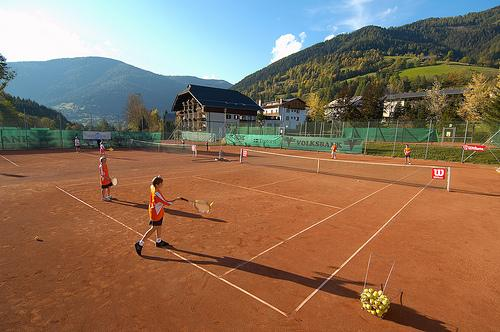Choose the correct referential expression: "The person in a black skirt is _____" Just standing there. What is the primary action being taken by the tennis player? A tennis player swinging a racket on an orange clay court. Based on the image description, determine whether or not the setting seems to be a professional or casual tennis game. The setting appears to be more casual, as there are various players, equipment, and clay courts. List three objects related to tennis that can be seen in the image. A tennis racket, a tennis ball, and a tennis court net. What objects can you find near the net and what color are they? A tennis ball near the net is white and the banner in the back is green. Describe the tennis court's surface and what makes it distinct. The tennis court's surface is orange and red clay, which gives it a unique look and texture. Imagine a brand using this image for an advertisement. Describe the core message they would be trying to convey. Experience the spirit and intensity of tennis on a clay court, surrounded by nature's astounding beauty. Identify the types of footwear worn by the various individuals in the image. White tennis shoes, black tennis shoes, and black sneakers. Describe the role of mountains and trees in this picture. Mountains and trees provide a serene, picturesque backdrop for the tennis game. Explain the surroundings of this tennis playing scene. The scene takes place on a red clay tennis court surrounded by two nets and a chalet, with a mountain range and tree-covered hills in the distance. 